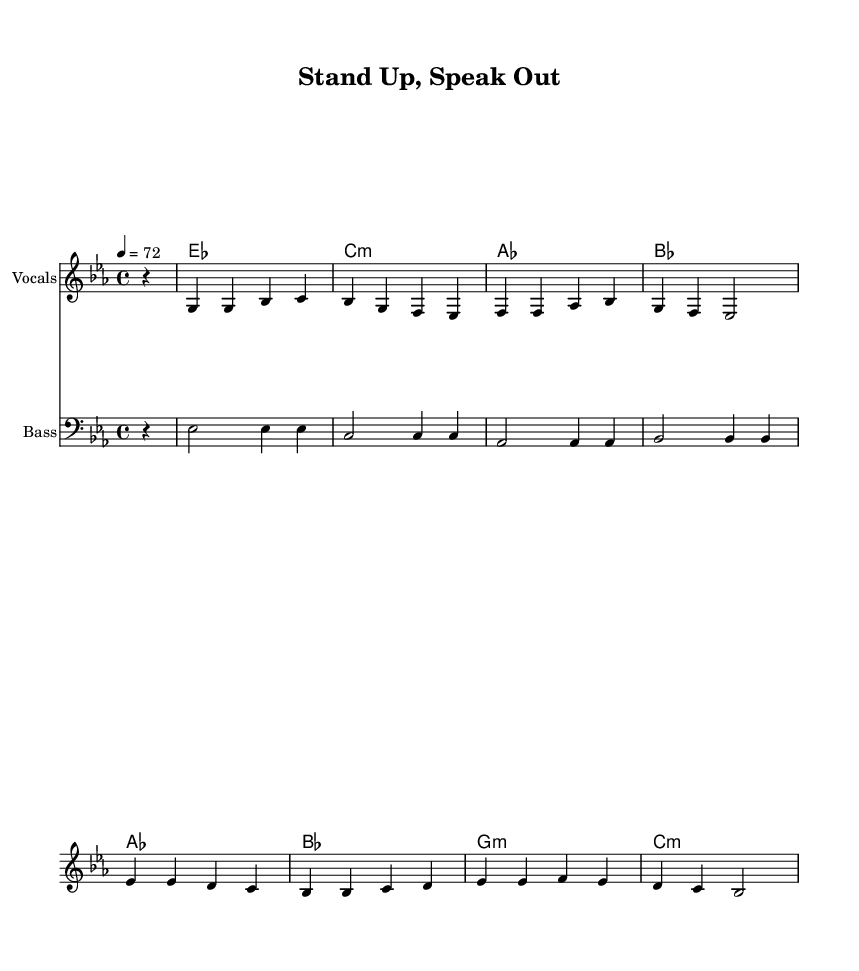What is the key signature of this music? The key signature is indicated at the beginning of the staff with two flats and is based on the notation for E-flat major.
Answer: E-flat major What is the time signature of the piece? The time signature appears at the beginning of the score and indicates how many beats are in each measure, which is represented as four beats per measure, shown as 4/4.
Answer: 4/4 What is the tempo indicated for this piece? The tempo marking is noted at the beginning, stating to play at a speed of 72 beats per minute, represented by the number after the tempo indication.
Answer: 72 How many measures are in the chorus section? The chorus section can be determined by counting the measures indicated below the lyrics and looking at the notation where the chorus lyrics are displayed, totaling four measures.
Answer: 4 What is the primary theme of the lyrics in the song? The lyrics express a call for social justice and athlete unity, indicated by phrases in both the verse and chorus sections that reflect these themes.
Answer: Athlete unity What chord follows the E-flat major chord in the chord progression? Investigating the chord progression, the next chord indicated after E-flat major is C minor, which follows immediately after in the sequence shown.
Answer: C minor How is the bass line structured in this piece? The bass line, following a similar rhythmic and melodic pattern as the melody, is presented in a continuous manner where each note corresponds with the chord structure.
Answer: Continuous pattern 